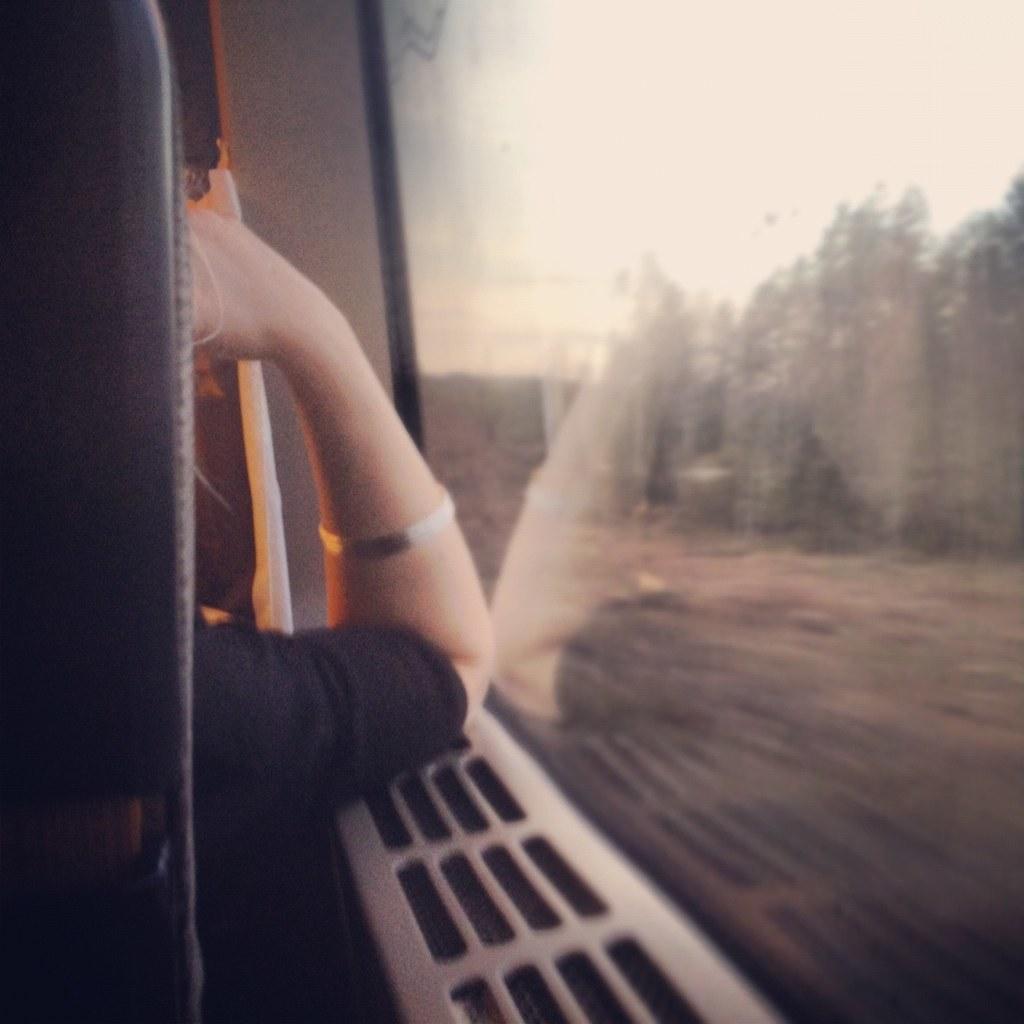In one or two sentences, can you explain what this image depicts? In this image, we can see a person sitting near the glass door and through the glass we can see some trees and at the top, there is sky. 